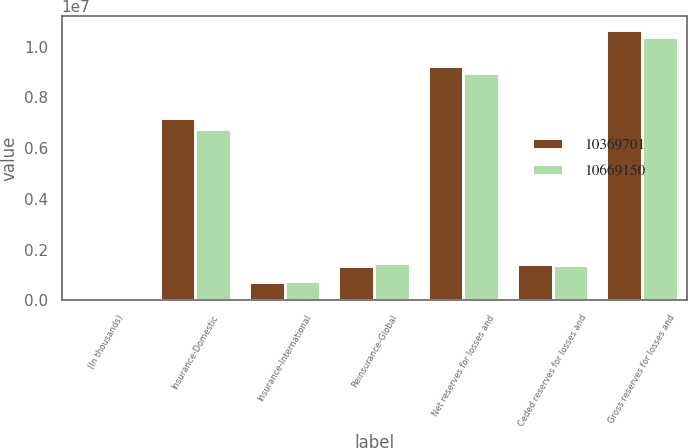Convert chart. <chart><loc_0><loc_0><loc_500><loc_500><stacked_bar_chart><ecel><fcel>(In thousands)<fcel>Insurance-Domestic<fcel>Insurance-International<fcel>Reinsurance-Global<fcel>Net reserves for losses and<fcel>Ceded reserves for losses and<fcel>Gross reserves for losses and<nl><fcel>1.03697e+07<fcel>2015<fcel>7.16964e+06<fcel>706553<fcel>1.36868e+06<fcel>9.24487e+06<fcel>1.42428e+06<fcel>1.06692e+07<nl><fcel>1.06692e+07<fcel>2014<fcel>6.76737e+06<fcel>750613<fcel>1.45265e+06<fcel>8.97064e+06<fcel>1.39906e+06<fcel>1.03697e+07<nl></chart> 